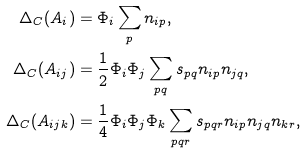Convert formula to latex. <formula><loc_0><loc_0><loc_500><loc_500>\Delta _ { C } ( A _ { i } ) & = \Phi _ { i } \sum _ { p } n _ { i p } , \\ \Delta _ { C } ( A _ { i j } ) & = \frac { 1 } { 2 } \Phi _ { i } \Phi _ { j } \sum _ { p q } s _ { p q } n _ { i p } n _ { j q } , \\ \Delta _ { C } ( A _ { i j k } ) & = \frac { 1 } { 4 } \Phi _ { i } \Phi _ { j } \Phi _ { k } \sum _ { p q r } s _ { p q r } n _ { i p } n _ { j q } n _ { k r } ,</formula> 